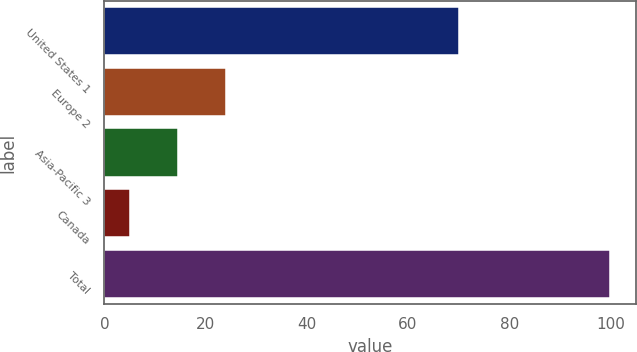<chart> <loc_0><loc_0><loc_500><loc_500><bar_chart><fcel>United States 1<fcel>Europe 2<fcel>Asia-Pacific 3<fcel>Canada<fcel>Total<nl><fcel>70<fcel>24<fcel>14.5<fcel>5<fcel>100<nl></chart> 